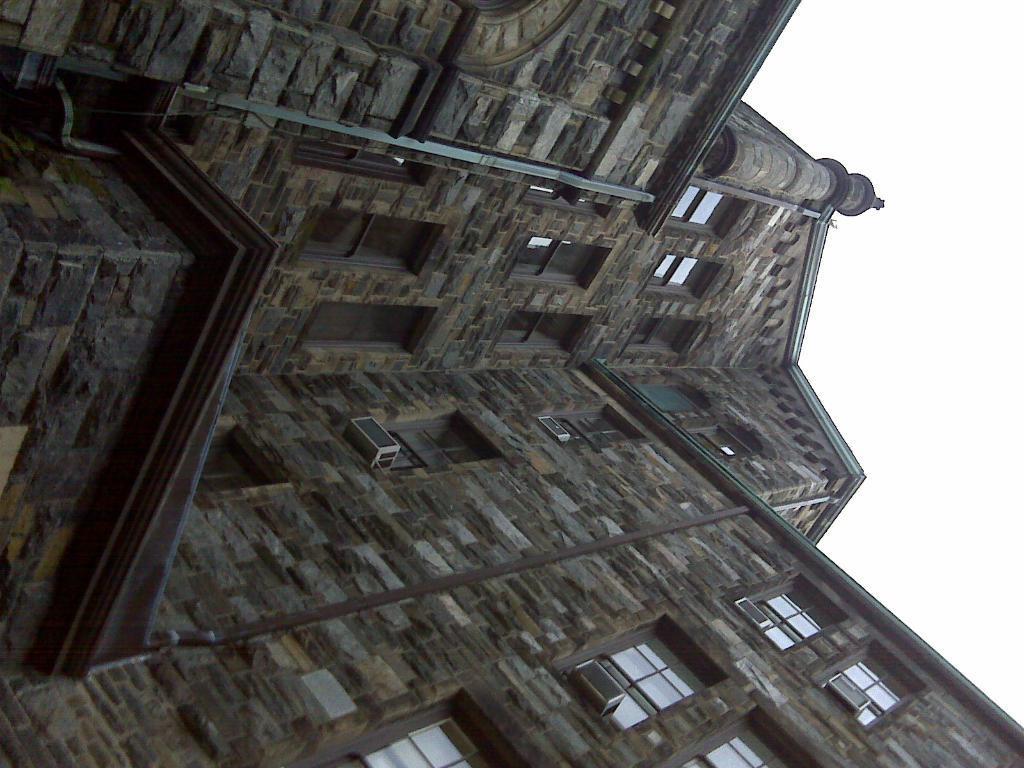In one or two sentences, can you explain what this image depicts? In this image we can see a building, windows, and AC condensers. On the right side of the image we can see sky. 